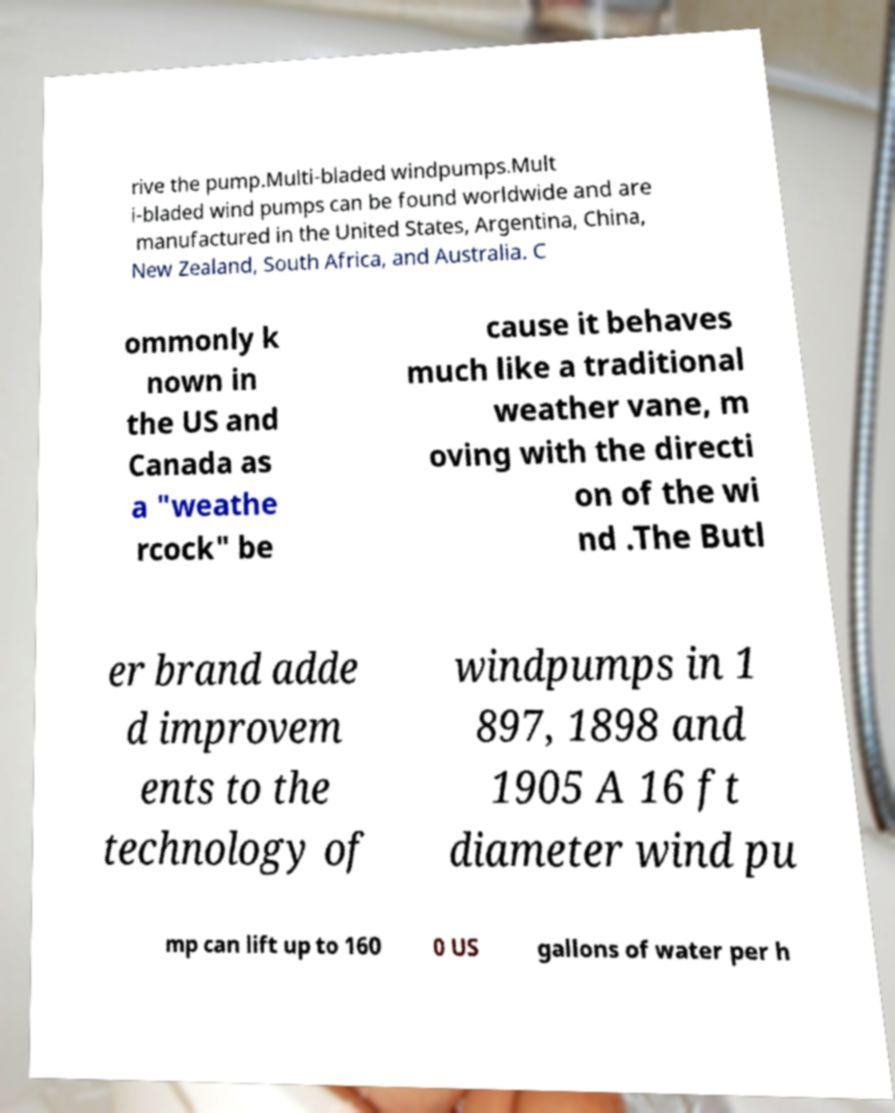Could you extract and type out the text from this image? rive the pump.Multi-bladed windpumps.Mult i-bladed wind pumps can be found worldwide and are manufactured in the United States, Argentina, China, New Zealand, South Africa, and Australia. C ommonly k nown in the US and Canada as a "weathe rcock" be cause it behaves much like a traditional weather vane, m oving with the directi on of the wi nd .The Butl er brand adde d improvem ents to the technology of windpumps in 1 897, 1898 and 1905 A 16 ft diameter wind pu mp can lift up to 160 0 US gallons of water per h 